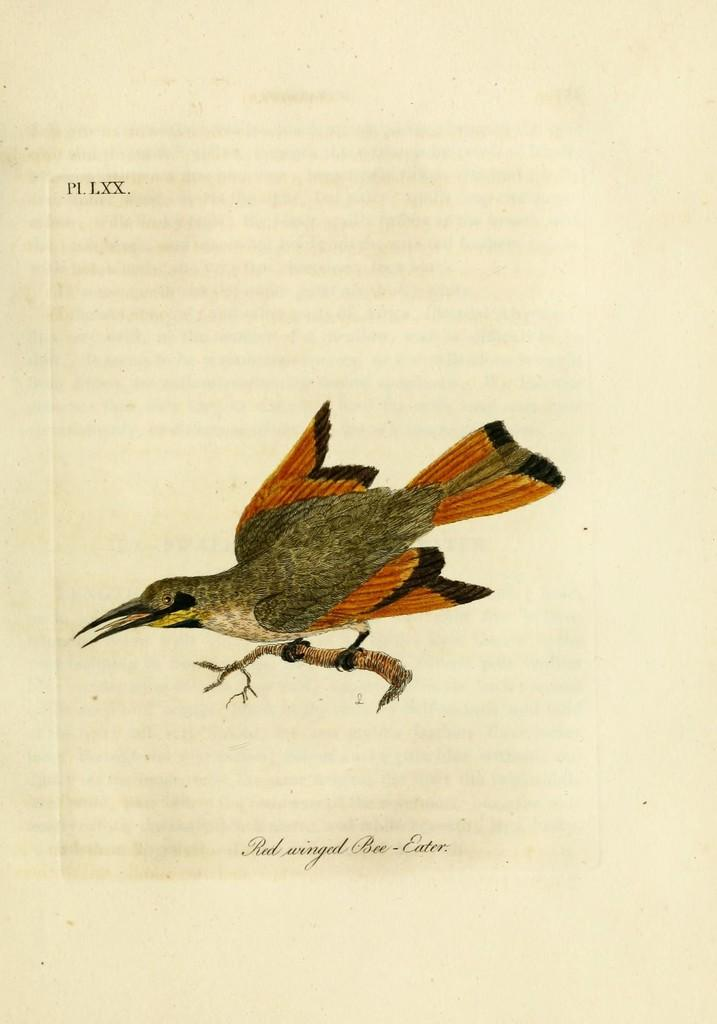What is depicted on the paper in the image? There is a picture of a bird on a paper in the image. What colors can be seen on the bird in the picture? The bird has orange and brown colors. What else is present in the picture besides the bird? There is a stem in the picture. What can be found on the paper along with the picture? There is text on the paper. Can you tell me how many properties are visible in the image? There are no properties visible in the image; it features a picture of a bird on a paper with text and a stem. Is there a sidewalk present in the image? There is no sidewalk present in the image. 